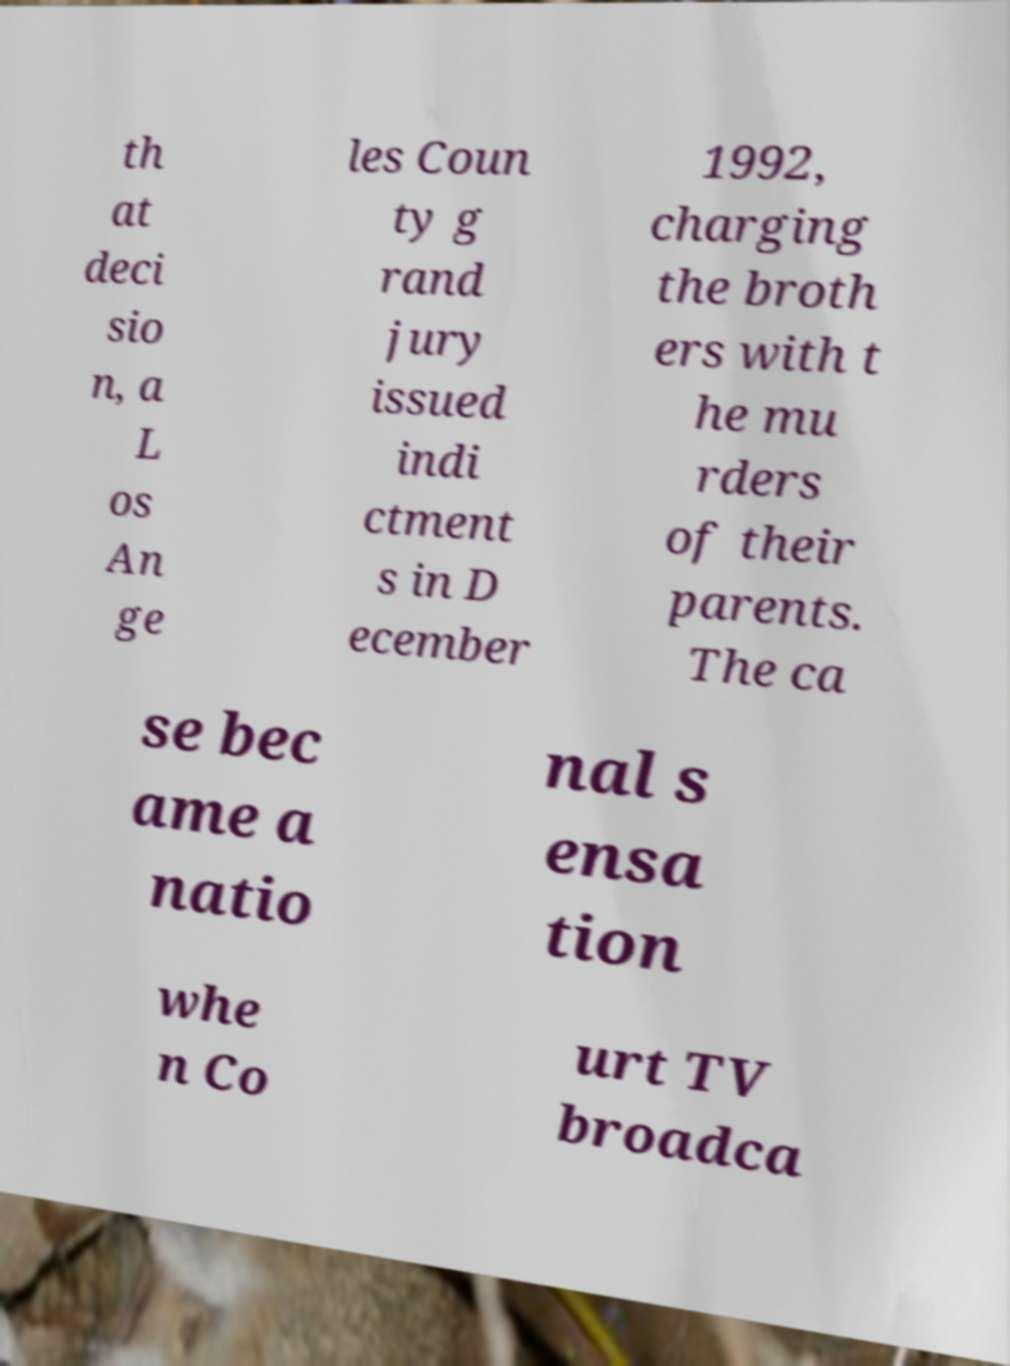What messages or text are displayed in this image? I need them in a readable, typed format. th at deci sio n, a L os An ge les Coun ty g rand jury issued indi ctment s in D ecember 1992, charging the broth ers with t he mu rders of their parents. The ca se bec ame a natio nal s ensa tion whe n Co urt TV broadca 